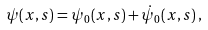<formula> <loc_0><loc_0><loc_500><loc_500>\psi ( x , s ) = \psi _ { 0 } ( x , s ) + \dot { \psi } _ { 0 } ( x , s ) \, ,</formula> 